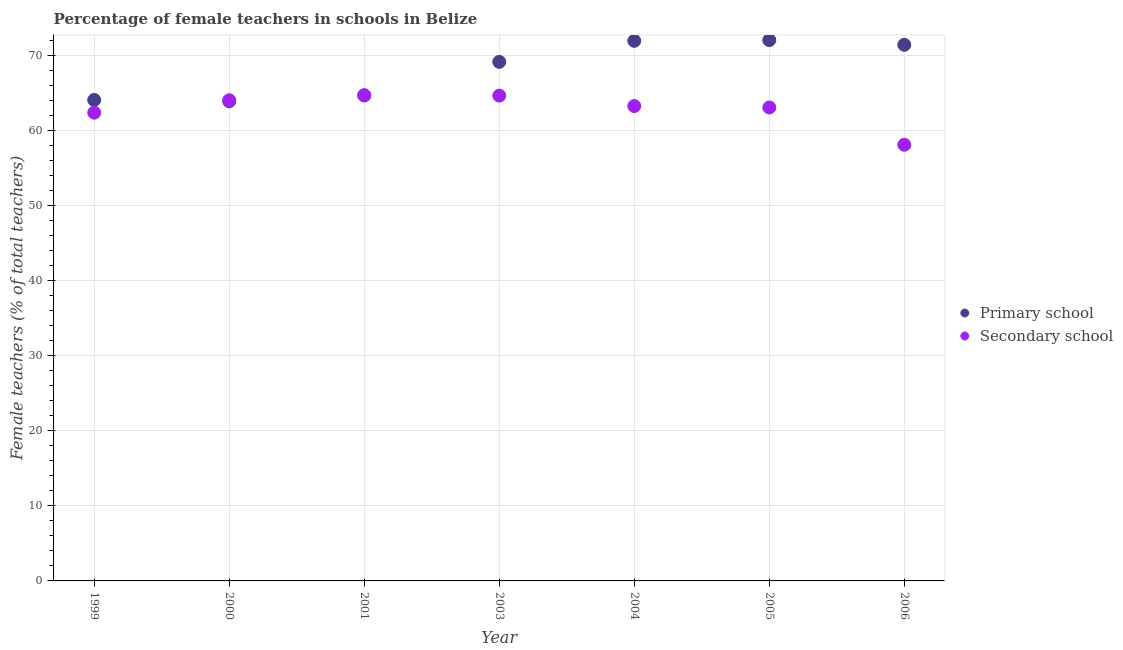What is the percentage of female teachers in secondary schools in 2004?
Provide a succinct answer. 63.29. Across all years, what is the maximum percentage of female teachers in primary schools?
Give a very brief answer. 72.07. Across all years, what is the minimum percentage of female teachers in primary schools?
Keep it short and to the point. 63.93. In which year was the percentage of female teachers in secondary schools maximum?
Ensure brevity in your answer.  2001. In which year was the percentage of female teachers in secondary schools minimum?
Provide a short and direct response. 2006. What is the total percentage of female teachers in primary schools in the graph?
Provide a succinct answer. 477.39. What is the difference between the percentage of female teachers in primary schools in 1999 and that in 2001?
Make the answer very short. -0.6. What is the difference between the percentage of female teachers in secondary schools in 2003 and the percentage of female teachers in primary schools in 1999?
Provide a succinct answer. 0.58. What is the average percentage of female teachers in secondary schools per year?
Your response must be concise. 62.91. In the year 1999, what is the difference between the percentage of female teachers in secondary schools and percentage of female teachers in primary schools?
Your answer should be very brief. -1.69. What is the ratio of the percentage of female teachers in secondary schools in 1999 to that in 2001?
Ensure brevity in your answer.  0.96. Is the percentage of female teachers in primary schools in 1999 less than that in 2004?
Keep it short and to the point. Yes. What is the difference between the highest and the second highest percentage of female teachers in primary schools?
Give a very brief answer. 0.1. What is the difference between the highest and the lowest percentage of female teachers in primary schools?
Keep it short and to the point. 8.15. Is the sum of the percentage of female teachers in secondary schools in 2000 and 2006 greater than the maximum percentage of female teachers in primary schools across all years?
Provide a short and direct response. Yes. Does the percentage of female teachers in secondary schools monotonically increase over the years?
Provide a short and direct response. No. Is the percentage of female teachers in secondary schools strictly less than the percentage of female teachers in primary schools over the years?
Your answer should be compact. No. How many dotlines are there?
Offer a very short reply. 2. How many years are there in the graph?
Make the answer very short. 7. Does the graph contain any zero values?
Give a very brief answer. No. Does the graph contain grids?
Give a very brief answer. Yes. Where does the legend appear in the graph?
Give a very brief answer. Center right. What is the title of the graph?
Make the answer very short. Percentage of female teachers in schools in Belize. Does "Investments" appear as one of the legend labels in the graph?
Provide a succinct answer. No. What is the label or title of the Y-axis?
Give a very brief answer. Female teachers (% of total teachers). What is the Female teachers (% of total teachers) in Primary school in 1999?
Make the answer very short. 64.1. What is the Female teachers (% of total teachers) of Secondary school in 1999?
Provide a succinct answer. 62.4. What is the Female teachers (% of total teachers) in Primary school in 2000?
Provide a succinct answer. 63.93. What is the Female teachers (% of total teachers) of Secondary school in 2000?
Give a very brief answer. 64.06. What is the Female teachers (% of total teachers) in Primary school in 2001?
Your response must be concise. 64.7. What is the Female teachers (% of total teachers) in Secondary school in 2001?
Provide a short and direct response. 64.73. What is the Female teachers (% of total teachers) in Primary school in 2003?
Ensure brevity in your answer.  69.17. What is the Female teachers (% of total teachers) of Secondary school in 2003?
Give a very brief answer. 64.67. What is the Female teachers (% of total teachers) in Primary school in 2004?
Ensure brevity in your answer.  71.98. What is the Female teachers (% of total teachers) in Secondary school in 2004?
Your response must be concise. 63.29. What is the Female teachers (% of total teachers) of Primary school in 2005?
Your response must be concise. 72.07. What is the Female teachers (% of total teachers) of Secondary school in 2005?
Your answer should be compact. 63.09. What is the Female teachers (% of total teachers) in Primary school in 2006?
Offer a terse response. 71.45. What is the Female teachers (% of total teachers) in Secondary school in 2006?
Give a very brief answer. 58.13. Across all years, what is the maximum Female teachers (% of total teachers) of Primary school?
Offer a very short reply. 72.07. Across all years, what is the maximum Female teachers (% of total teachers) in Secondary school?
Keep it short and to the point. 64.73. Across all years, what is the minimum Female teachers (% of total teachers) in Primary school?
Your answer should be very brief. 63.93. Across all years, what is the minimum Female teachers (% of total teachers) in Secondary school?
Provide a succinct answer. 58.13. What is the total Female teachers (% of total teachers) in Primary school in the graph?
Provide a succinct answer. 477.39. What is the total Female teachers (% of total teachers) of Secondary school in the graph?
Provide a short and direct response. 440.37. What is the difference between the Female teachers (% of total teachers) of Primary school in 1999 and that in 2000?
Your answer should be very brief. 0.17. What is the difference between the Female teachers (% of total teachers) of Secondary school in 1999 and that in 2000?
Keep it short and to the point. -1.65. What is the difference between the Female teachers (% of total teachers) of Primary school in 1999 and that in 2001?
Your answer should be compact. -0.6. What is the difference between the Female teachers (% of total teachers) of Secondary school in 1999 and that in 2001?
Make the answer very short. -2.32. What is the difference between the Female teachers (% of total teachers) of Primary school in 1999 and that in 2003?
Give a very brief answer. -5.08. What is the difference between the Female teachers (% of total teachers) in Secondary school in 1999 and that in 2003?
Keep it short and to the point. -2.27. What is the difference between the Female teachers (% of total teachers) in Primary school in 1999 and that in 2004?
Your answer should be compact. -7.88. What is the difference between the Female teachers (% of total teachers) of Secondary school in 1999 and that in 2004?
Make the answer very short. -0.88. What is the difference between the Female teachers (% of total teachers) of Primary school in 1999 and that in 2005?
Provide a succinct answer. -7.98. What is the difference between the Female teachers (% of total teachers) of Secondary school in 1999 and that in 2005?
Your answer should be compact. -0.69. What is the difference between the Female teachers (% of total teachers) in Primary school in 1999 and that in 2006?
Keep it short and to the point. -7.35. What is the difference between the Female teachers (% of total teachers) of Secondary school in 1999 and that in 2006?
Your response must be concise. 4.28. What is the difference between the Female teachers (% of total teachers) of Primary school in 2000 and that in 2001?
Your answer should be very brief. -0.77. What is the difference between the Female teachers (% of total teachers) of Secondary school in 2000 and that in 2001?
Your answer should be very brief. -0.67. What is the difference between the Female teachers (% of total teachers) of Primary school in 2000 and that in 2003?
Offer a very short reply. -5.25. What is the difference between the Female teachers (% of total teachers) of Secondary school in 2000 and that in 2003?
Ensure brevity in your answer.  -0.62. What is the difference between the Female teachers (% of total teachers) of Primary school in 2000 and that in 2004?
Your answer should be compact. -8.05. What is the difference between the Female teachers (% of total teachers) of Secondary school in 2000 and that in 2004?
Make the answer very short. 0.77. What is the difference between the Female teachers (% of total teachers) of Primary school in 2000 and that in 2005?
Your response must be concise. -8.15. What is the difference between the Female teachers (% of total teachers) of Secondary school in 2000 and that in 2005?
Ensure brevity in your answer.  0.96. What is the difference between the Female teachers (% of total teachers) of Primary school in 2000 and that in 2006?
Keep it short and to the point. -7.52. What is the difference between the Female teachers (% of total teachers) in Secondary school in 2000 and that in 2006?
Your answer should be very brief. 5.93. What is the difference between the Female teachers (% of total teachers) of Primary school in 2001 and that in 2003?
Provide a succinct answer. -4.47. What is the difference between the Female teachers (% of total teachers) in Secondary school in 2001 and that in 2003?
Offer a very short reply. 0.06. What is the difference between the Female teachers (% of total teachers) of Primary school in 2001 and that in 2004?
Your answer should be very brief. -7.28. What is the difference between the Female teachers (% of total teachers) of Secondary school in 2001 and that in 2004?
Provide a short and direct response. 1.44. What is the difference between the Female teachers (% of total teachers) of Primary school in 2001 and that in 2005?
Offer a very short reply. -7.37. What is the difference between the Female teachers (% of total teachers) in Secondary school in 2001 and that in 2005?
Make the answer very short. 1.63. What is the difference between the Female teachers (% of total teachers) of Primary school in 2001 and that in 2006?
Make the answer very short. -6.75. What is the difference between the Female teachers (% of total teachers) of Secondary school in 2001 and that in 2006?
Give a very brief answer. 6.6. What is the difference between the Female teachers (% of total teachers) in Primary school in 2003 and that in 2004?
Keep it short and to the point. -2.8. What is the difference between the Female teachers (% of total teachers) in Secondary school in 2003 and that in 2004?
Offer a very short reply. 1.39. What is the difference between the Female teachers (% of total teachers) of Primary school in 2003 and that in 2005?
Provide a short and direct response. -2.9. What is the difference between the Female teachers (% of total teachers) of Secondary school in 2003 and that in 2005?
Your answer should be very brief. 1.58. What is the difference between the Female teachers (% of total teachers) of Primary school in 2003 and that in 2006?
Your answer should be compact. -2.27. What is the difference between the Female teachers (% of total teachers) of Secondary school in 2003 and that in 2006?
Give a very brief answer. 6.54. What is the difference between the Female teachers (% of total teachers) in Primary school in 2004 and that in 2005?
Offer a very short reply. -0.1. What is the difference between the Female teachers (% of total teachers) of Secondary school in 2004 and that in 2005?
Offer a terse response. 0.19. What is the difference between the Female teachers (% of total teachers) of Primary school in 2004 and that in 2006?
Give a very brief answer. 0.53. What is the difference between the Female teachers (% of total teachers) in Secondary school in 2004 and that in 2006?
Give a very brief answer. 5.16. What is the difference between the Female teachers (% of total teachers) of Primary school in 2005 and that in 2006?
Ensure brevity in your answer.  0.63. What is the difference between the Female teachers (% of total teachers) of Secondary school in 2005 and that in 2006?
Your response must be concise. 4.97. What is the difference between the Female teachers (% of total teachers) of Primary school in 1999 and the Female teachers (% of total teachers) of Secondary school in 2000?
Give a very brief answer. 0.04. What is the difference between the Female teachers (% of total teachers) of Primary school in 1999 and the Female teachers (% of total teachers) of Secondary school in 2001?
Keep it short and to the point. -0.63. What is the difference between the Female teachers (% of total teachers) of Primary school in 1999 and the Female teachers (% of total teachers) of Secondary school in 2003?
Your response must be concise. -0.58. What is the difference between the Female teachers (% of total teachers) in Primary school in 1999 and the Female teachers (% of total teachers) in Secondary school in 2004?
Your response must be concise. 0.81. What is the difference between the Female teachers (% of total teachers) of Primary school in 1999 and the Female teachers (% of total teachers) of Secondary school in 2006?
Your answer should be compact. 5.97. What is the difference between the Female teachers (% of total teachers) in Primary school in 2000 and the Female teachers (% of total teachers) in Secondary school in 2001?
Provide a succinct answer. -0.8. What is the difference between the Female teachers (% of total teachers) of Primary school in 2000 and the Female teachers (% of total teachers) of Secondary school in 2003?
Your answer should be very brief. -0.75. What is the difference between the Female teachers (% of total teachers) of Primary school in 2000 and the Female teachers (% of total teachers) of Secondary school in 2004?
Offer a very short reply. 0.64. What is the difference between the Female teachers (% of total teachers) of Primary school in 2000 and the Female teachers (% of total teachers) of Secondary school in 2005?
Make the answer very short. 0.83. What is the difference between the Female teachers (% of total teachers) of Primary school in 2000 and the Female teachers (% of total teachers) of Secondary school in 2006?
Your answer should be very brief. 5.8. What is the difference between the Female teachers (% of total teachers) of Primary school in 2001 and the Female teachers (% of total teachers) of Secondary school in 2003?
Keep it short and to the point. 0.03. What is the difference between the Female teachers (% of total teachers) in Primary school in 2001 and the Female teachers (% of total teachers) in Secondary school in 2004?
Provide a succinct answer. 1.41. What is the difference between the Female teachers (% of total teachers) of Primary school in 2001 and the Female teachers (% of total teachers) of Secondary school in 2005?
Your answer should be compact. 1.61. What is the difference between the Female teachers (% of total teachers) of Primary school in 2001 and the Female teachers (% of total teachers) of Secondary school in 2006?
Your response must be concise. 6.57. What is the difference between the Female teachers (% of total teachers) in Primary school in 2003 and the Female teachers (% of total teachers) in Secondary school in 2004?
Offer a very short reply. 5.89. What is the difference between the Female teachers (% of total teachers) of Primary school in 2003 and the Female teachers (% of total teachers) of Secondary school in 2005?
Offer a very short reply. 6.08. What is the difference between the Female teachers (% of total teachers) in Primary school in 2003 and the Female teachers (% of total teachers) in Secondary school in 2006?
Provide a short and direct response. 11.05. What is the difference between the Female teachers (% of total teachers) of Primary school in 2004 and the Female teachers (% of total teachers) of Secondary school in 2005?
Your answer should be very brief. 8.88. What is the difference between the Female teachers (% of total teachers) of Primary school in 2004 and the Female teachers (% of total teachers) of Secondary school in 2006?
Offer a terse response. 13.85. What is the difference between the Female teachers (% of total teachers) in Primary school in 2005 and the Female teachers (% of total teachers) in Secondary school in 2006?
Offer a terse response. 13.95. What is the average Female teachers (% of total teachers) in Primary school per year?
Your response must be concise. 68.2. What is the average Female teachers (% of total teachers) of Secondary school per year?
Give a very brief answer. 62.91. In the year 1999, what is the difference between the Female teachers (% of total teachers) of Primary school and Female teachers (% of total teachers) of Secondary school?
Offer a terse response. 1.69. In the year 2000, what is the difference between the Female teachers (% of total teachers) in Primary school and Female teachers (% of total teachers) in Secondary school?
Provide a short and direct response. -0.13. In the year 2001, what is the difference between the Female teachers (% of total teachers) in Primary school and Female teachers (% of total teachers) in Secondary school?
Your answer should be very brief. -0.03. In the year 2003, what is the difference between the Female teachers (% of total teachers) of Primary school and Female teachers (% of total teachers) of Secondary school?
Provide a short and direct response. 4.5. In the year 2004, what is the difference between the Female teachers (% of total teachers) in Primary school and Female teachers (% of total teachers) in Secondary school?
Provide a succinct answer. 8.69. In the year 2005, what is the difference between the Female teachers (% of total teachers) in Primary school and Female teachers (% of total teachers) in Secondary school?
Offer a very short reply. 8.98. In the year 2006, what is the difference between the Female teachers (% of total teachers) in Primary school and Female teachers (% of total teachers) in Secondary school?
Offer a very short reply. 13.32. What is the ratio of the Female teachers (% of total teachers) of Primary school in 1999 to that in 2000?
Your answer should be compact. 1. What is the ratio of the Female teachers (% of total teachers) of Secondary school in 1999 to that in 2000?
Give a very brief answer. 0.97. What is the ratio of the Female teachers (% of total teachers) of Secondary school in 1999 to that in 2001?
Offer a terse response. 0.96. What is the ratio of the Female teachers (% of total teachers) of Primary school in 1999 to that in 2003?
Your answer should be very brief. 0.93. What is the ratio of the Female teachers (% of total teachers) of Secondary school in 1999 to that in 2003?
Make the answer very short. 0.96. What is the ratio of the Female teachers (% of total teachers) in Primary school in 1999 to that in 2004?
Offer a terse response. 0.89. What is the ratio of the Female teachers (% of total teachers) in Secondary school in 1999 to that in 2004?
Your response must be concise. 0.99. What is the ratio of the Female teachers (% of total teachers) in Primary school in 1999 to that in 2005?
Keep it short and to the point. 0.89. What is the ratio of the Female teachers (% of total teachers) of Primary school in 1999 to that in 2006?
Provide a succinct answer. 0.9. What is the ratio of the Female teachers (% of total teachers) in Secondary school in 1999 to that in 2006?
Keep it short and to the point. 1.07. What is the ratio of the Female teachers (% of total teachers) in Primary school in 2000 to that in 2001?
Your response must be concise. 0.99. What is the ratio of the Female teachers (% of total teachers) in Primary school in 2000 to that in 2003?
Your answer should be very brief. 0.92. What is the ratio of the Female teachers (% of total teachers) in Primary school in 2000 to that in 2004?
Provide a succinct answer. 0.89. What is the ratio of the Female teachers (% of total teachers) of Secondary school in 2000 to that in 2004?
Ensure brevity in your answer.  1.01. What is the ratio of the Female teachers (% of total teachers) in Primary school in 2000 to that in 2005?
Make the answer very short. 0.89. What is the ratio of the Female teachers (% of total teachers) of Secondary school in 2000 to that in 2005?
Keep it short and to the point. 1.02. What is the ratio of the Female teachers (% of total teachers) of Primary school in 2000 to that in 2006?
Make the answer very short. 0.89. What is the ratio of the Female teachers (% of total teachers) in Secondary school in 2000 to that in 2006?
Give a very brief answer. 1.1. What is the ratio of the Female teachers (% of total teachers) in Primary school in 2001 to that in 2003?
Keep it short and to the point. 0.94. What is the ratio of the Female teachers (% of total teachers) in Primary school in 2001 to that in 2004?
Your response must be concise. 0.9. What is the ratio of the Female teachers (% of total teachers) in Secondary school in 2001 to that in 2004?
Provide a short and direct response. 1.02. What is the ratio of the Female teachers (% of total teachers) of Primary school in 2001 to that in 2005?
Make the answer very short. 0.9. What is the ratio of the Female teachers (% of total teachers) in Secondary school in 2001 to that in 2005?
Ensure brevity in your answer.  1.03. What is the ratio of the Female teachers (% of total teachers) of Primary school in 2001 to that in 2006?
Make the answer very short. 0.91. What is the ratio of the Female teachers (% of total teachers) in Secondary school in 2001 to that in 2006?
Make the answer very short. 1.11. What is the ratio of the Female teachers (% of total teachers) in Secondary school in 2003 to that in 2004?
Give a very brief answer. 1.02. What is the ratio of the Female teachers (% of total teachers) of Primary school in 2003 to that in 2005?
Offer a very short reply. 0.96. What is the ratio of the Female teachers (% of total teachers) in Secondary school in 2003 to that in 2005?
Give a very brief answer. 1.02. What is the ratio of the Female teachers (% of total teachers) in Primary school in 2003 to that in 2006?
Offer a very short reply. 0.97. What is the ratio of the Female teachers (% of total teachers) in Secondary school in 2003 to that in 2006?
Provide a short and direct response. 1.11. What is the ratio of the Female teachers (% of total teachers) in Primary school in 2004 to that in 2005?
Your answer should be very brief. 1. What is the ratio of the Female teachers (% of total teachers) in Secondary school in 2004 to that in 2005?
Your answer should be very brief. 1. What is the ratio of the Female teachers (% of total teachers) in Primary school in 2004 to that in 2006?
Offer a very short reply. 1.01. What is the ratio of the Female teachers (% of total teachers) of Secondary school in 2004 to that in 2006?
Give a very brief answer. 1.09. What is the ratio of the Female teachers (% of total teachers) of Primary school in 2005 to that in 2006?
Your response must be concise. 1.01. What is the ratio of the Female teachers (% of total teachers) in Secondary school in 2005 to that in 2006?
Offer a terse response. 1.09. What is the difference between the highest and the second highest Female teachers (% of total teachers) of Primary school?
Offer a terse response. 0.1. What is the difference between the highest and the second highest Female teachers (% of total teachers) in Secondary school?
Your response must be concise. 0.06. What is the difference between the highest and the lowest Female teachers (% of total teachers) in Primary school?
Keep it short and to the point. 8.15. What is the difference between the highest and the lowest Female teachers (% of total teachers) in Secondary school?
Provide a succinct answer. 6.6. 